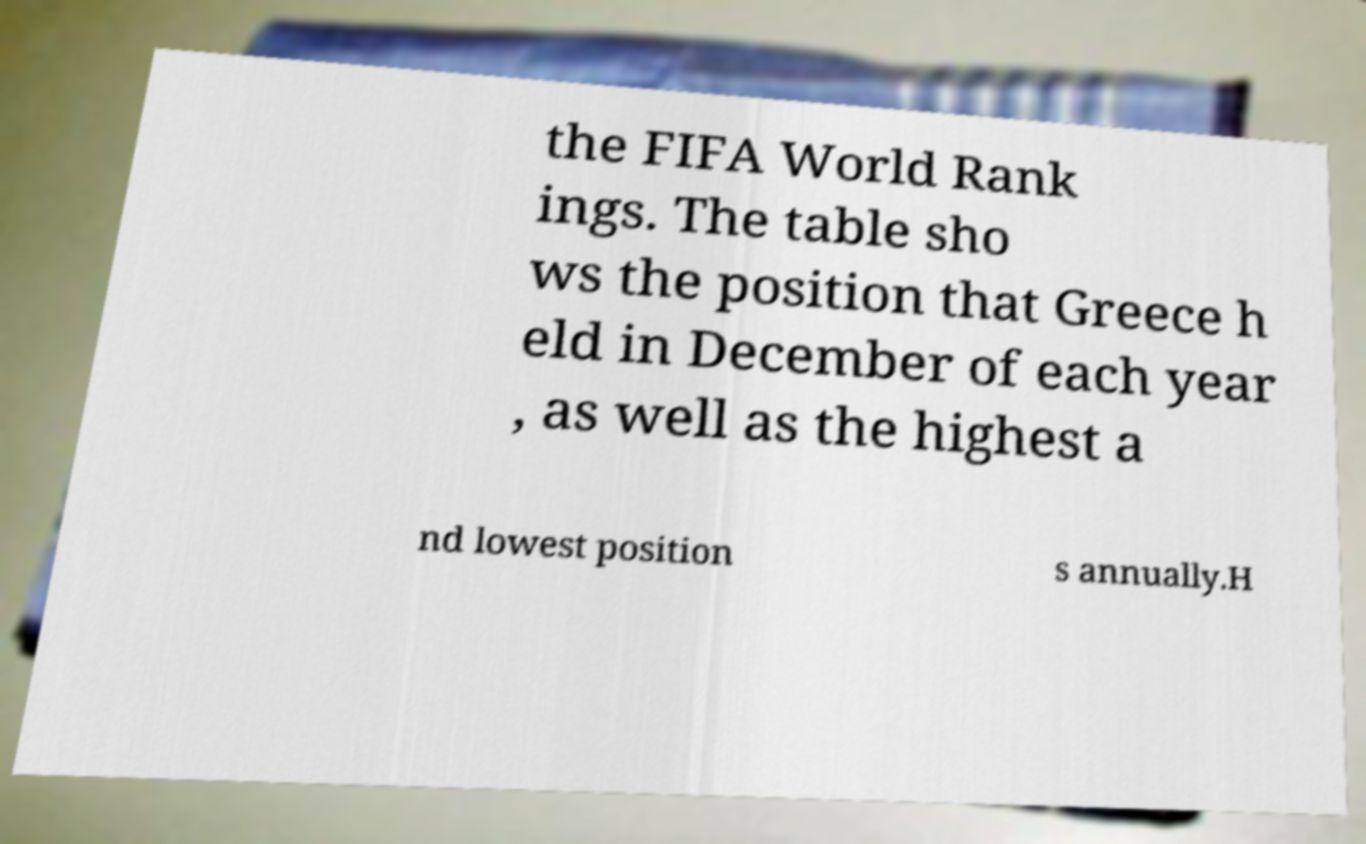Can you read and provide the text displayed in the image?This photo seems to have some interesting text. Can you extract and type it out for me? the FIFA World Rank ings. The table sho ws the position that Greece h eld in December of each year , as well as the highest a nd lowest position s annually.H 